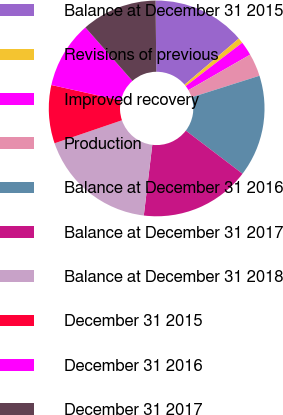Convert chart to OTSL. <chart><loc_0><loc_0><loc_500><loc_500><pie_chart><fcel>Balance at December 31 2015<fcel>Revisions of previous<fcel>Improved recovery<fcel>Production<fcel>Balance at December 31 2016<fcel>Balance at December 31 2017<fcel>Balance at December 31 2018<fcel>December 31 2015<fcel>December 31 2016<fcel>December 31 2017<nl><fcel>13.94%<fcel>0.8%<fcel>2.11%<fcel>3.41%<fcel>15.25%<fcel>16.55%<fcel>17.86%<fcel>8.72%<fcel>10.03%<fcel>11.33%<nl></chart> 